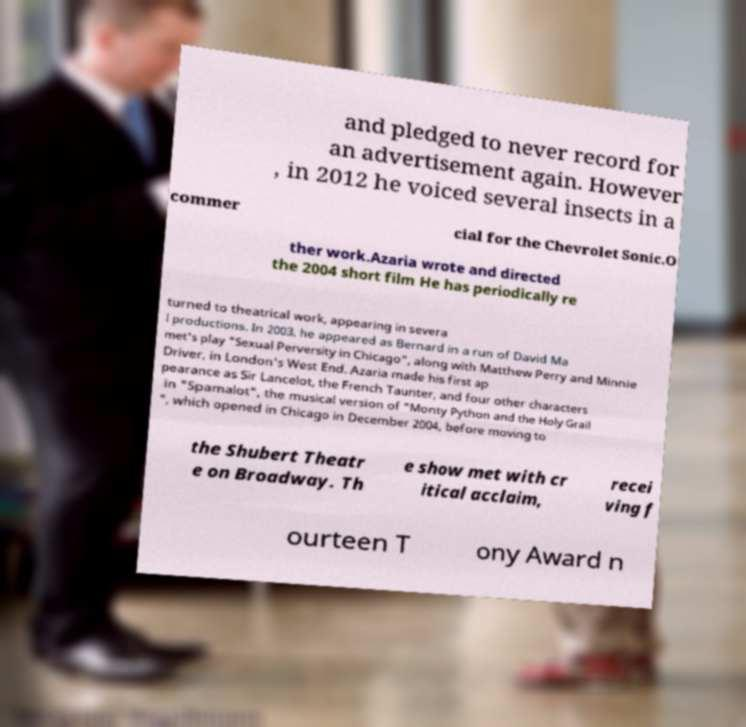There's text embedded in this image that I need extracted. Can you transcribe it verbatim? and pledged to never record for an advertisement again. However , in 2012 he voiced several insects in a commer cial for the Chevrolet Sonic.O ther work.Azaria wrote and directed the 2004 short film He has periodically re turned to theatrical work, appearing in severa l productions. In 2003, he appeared as Bernard in a run of David Ma met's play "Sexual Perversity in Chicago", along with Matthew Perry and Minnie Driver, in London's West End. Azaria made his first ap pearance as Sir Lancelot, the French Taunter, and four other characters in "Spamalot", the musical version of "Monty Python and the Holy Grail ", which opened in Chicago in December 2004, before moving to the Shubert Theatr e on Broadway. Th e show met with cr itical acclaim, recei ving f ourteen T ony Award n 